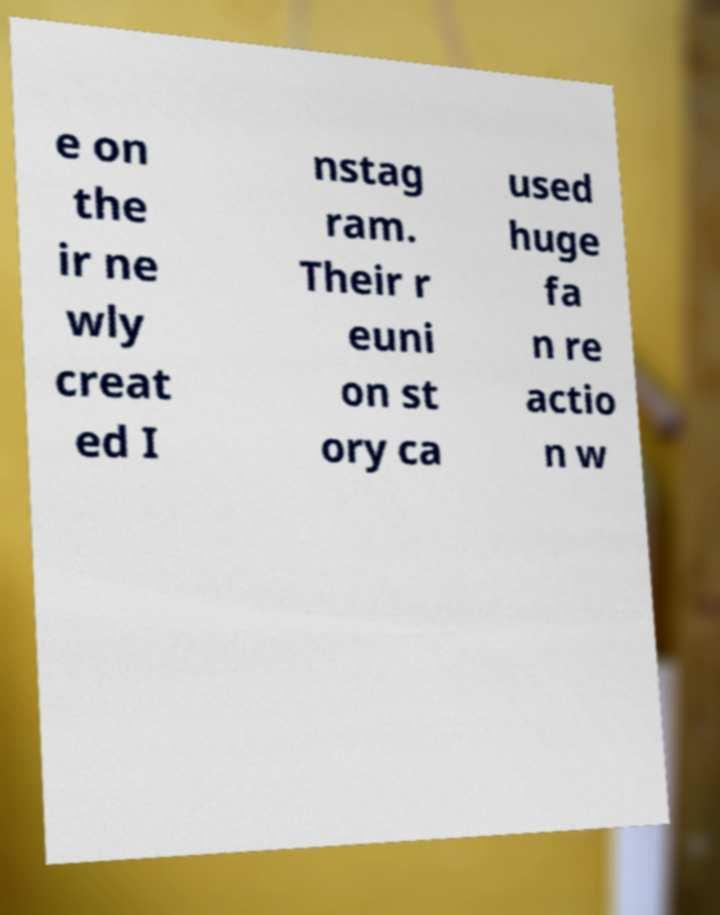Please read and relay the text visible in this image. What does it say? e on the ir ne wly creat ed I nstag ram. Their r euni on st ory ca used huge fa n re actio n w 